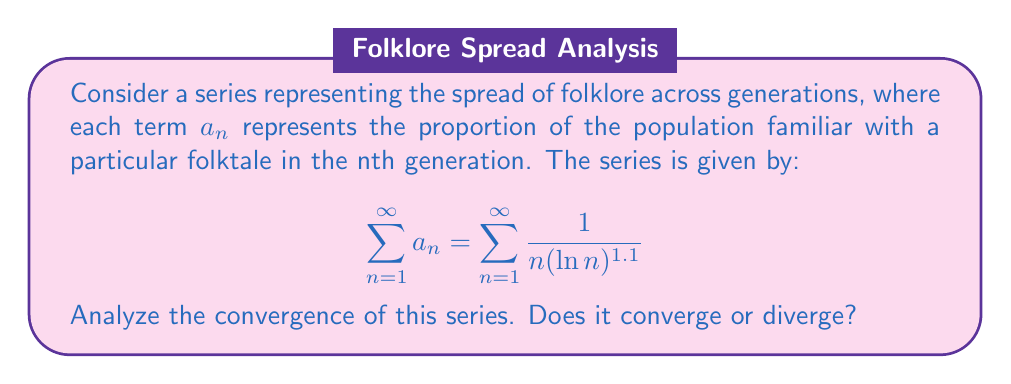What is the answer to this math problem? To analyze the convergence of this series, we can use the integral test. First, let's define the function $f(x)$ that corresponds to the general term of our series:

$$f(x) = \frac{1}{x(\ln x)^{1.1}}$$

Now, we need to check if this function satisfies the conditions for the integral test:

1. $f(x)$ is continuous for $x \geq 1$
2. $f(x)$ is decreasing for $x \geq 1$
3. $f(x)$ is positive for $x \geq 1$

All these conditions are satisfied for our function.

According to the integral test, the series converges if and only if the improper integral converges:

$$\int_{1}^{\infty} \frac{1}{x(\ln x)^{1.1}} dx$$

Let's evaluate this integral:

$$\begin{align}
\int \frac{1}{x(\ln x)^{1.1}} dx &= -\frac{1}{0.1(\ln x)^{0.1}} + C \\
&= -10(\ln x)^{-0.1} + C
\end{align}$$

Now, let's find the limit:

$$\begin{align}
\lim_{b \to \infty} \int_{1}^{b} \frac{1}{x(\ln x)^{1.1}} dx &= \lim_{b \to \infty} \left[-10(\ln b)^{-0.1} + 10(\ln 1)^{-0.1}\right] \\
&= \lim_{b \to \infty} \left[-10(\ln b)^{-0.1} + \infty\right] \\
&= \infty - \infty \text{ (indeterminate form)}
\end{align}$$

To resolve this indeterminate form, we can use L'Hôpital's rule or observe that $(\ln b)^{-0.1}$ approaches 0 as $b$ approaches infinity.

Therefore, the improper integral converges, and by the integral test, our original series converges as well.

This result suggests that the spread of folklore across generations, as modeled by this series, reaches a finite limit, implying that the folktale's reach stabilizes over time.
Answer: The series $\sum_{n=1}^{\infty} \frac{1}{n(\ln n)^{1.1}}$ converges. 